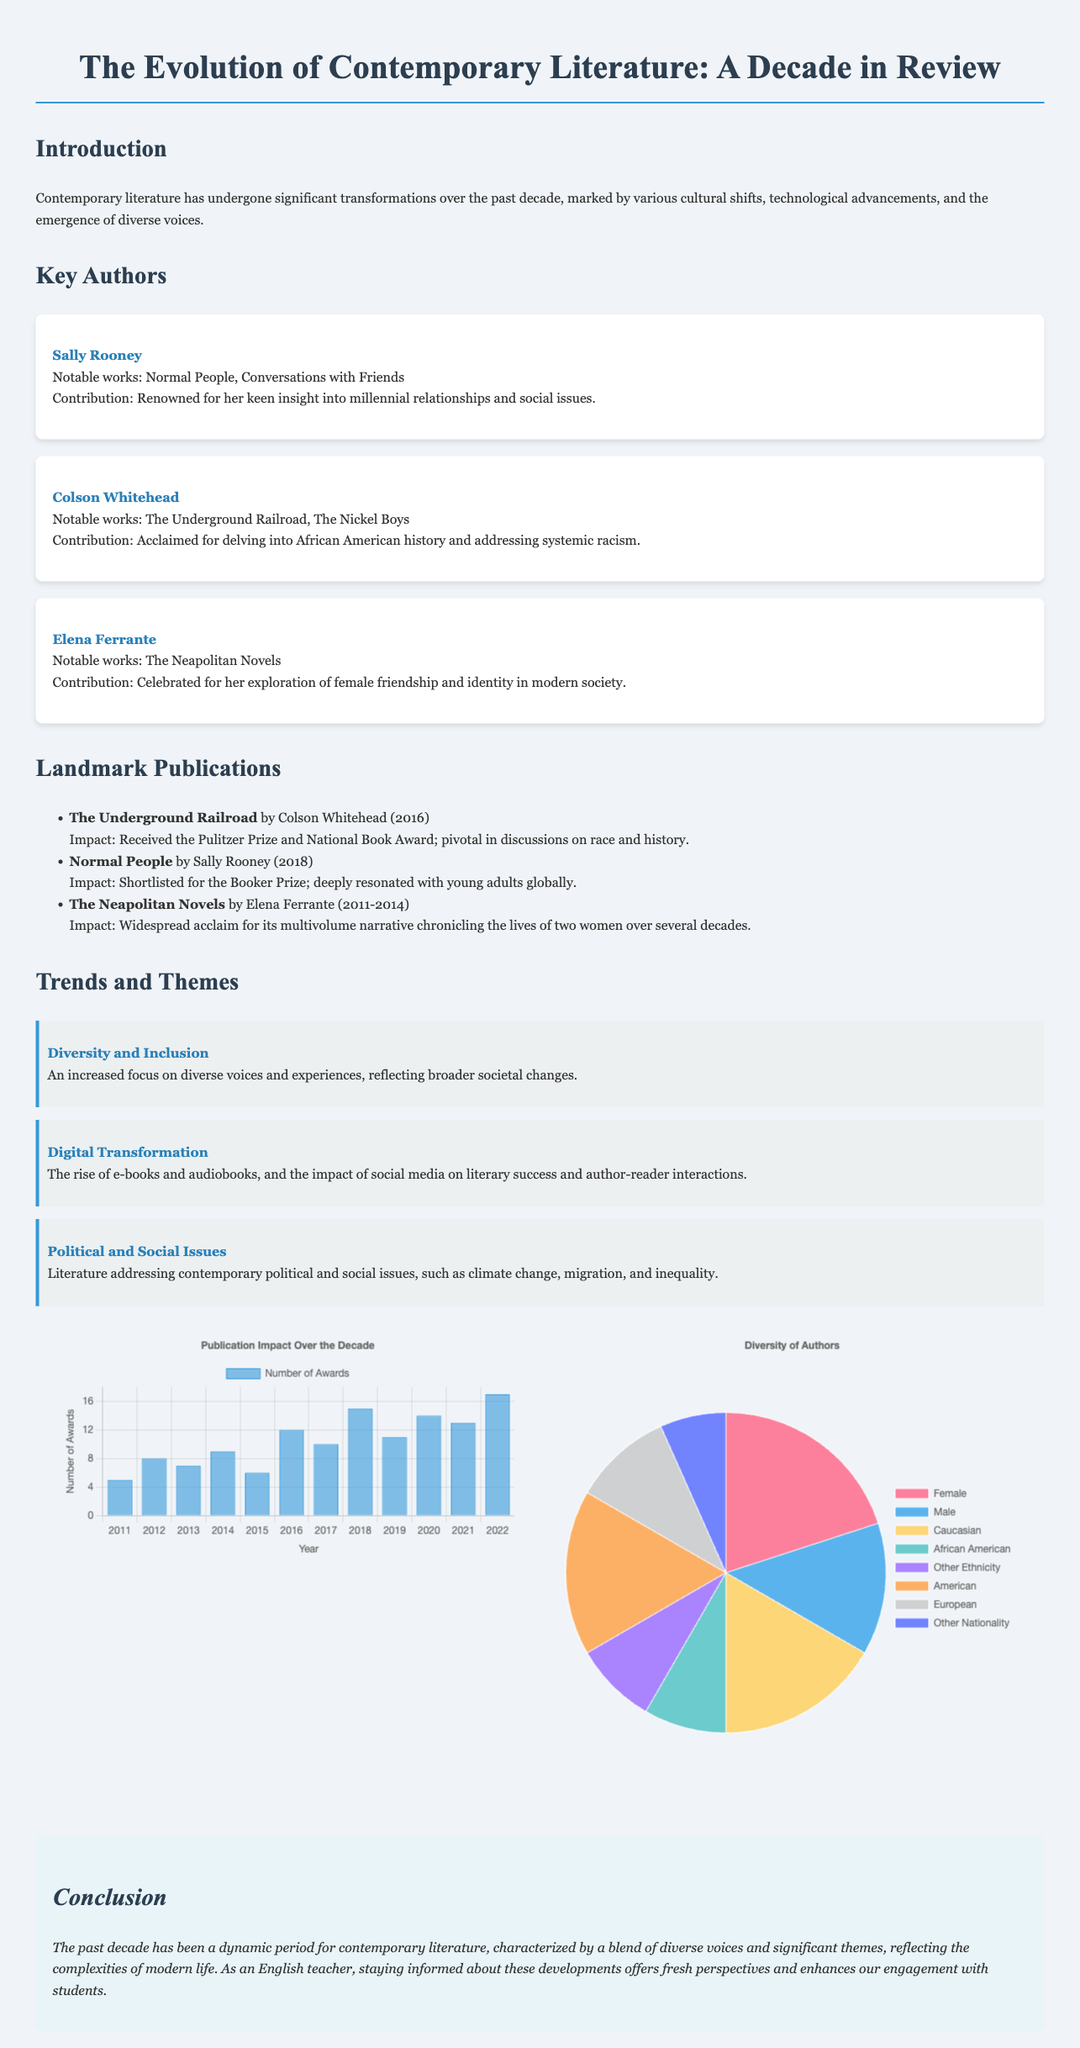What is the title of the document? The title is displayed prominently at the top of the document.
Answer: The Evolution of Contemporary Literature: A Decade in Review Who is the author of "The Underground Railroad"? The notable works listed under key authors indicate the respective authors.
Answer: Colson Whitehead In what year was "Normal People" published? The landmark publications section includes the publication year for each book.
Answer: 2018 How many awards were given in the year 2016? The data in the publication impact chart provides the number of awards by year.
Answer: 12 What theme focuses on the rise of e-books and audiobooks? The trends and themes section lists key themes impacting contemporary literature.
Answer: Digital Transformation What percentage of authors are female according to the diversity chart? The diversity chart provides visual information on the representation of different demographics.
Answer: 60 Which author is known for the Neapolitan Novels? The authors section identifies the works associated with each key author.
Answer: Elena Ferrante What year had the highest number of awards? Analysis of the publication impact chart reveals the peak year for awards.
Answer: 2022 What color represents African American authors in the diversity chart? The color coding in the diversity chart provides information about categories of authors.
Answer: rgba(75, 192, 192, 0.8) 